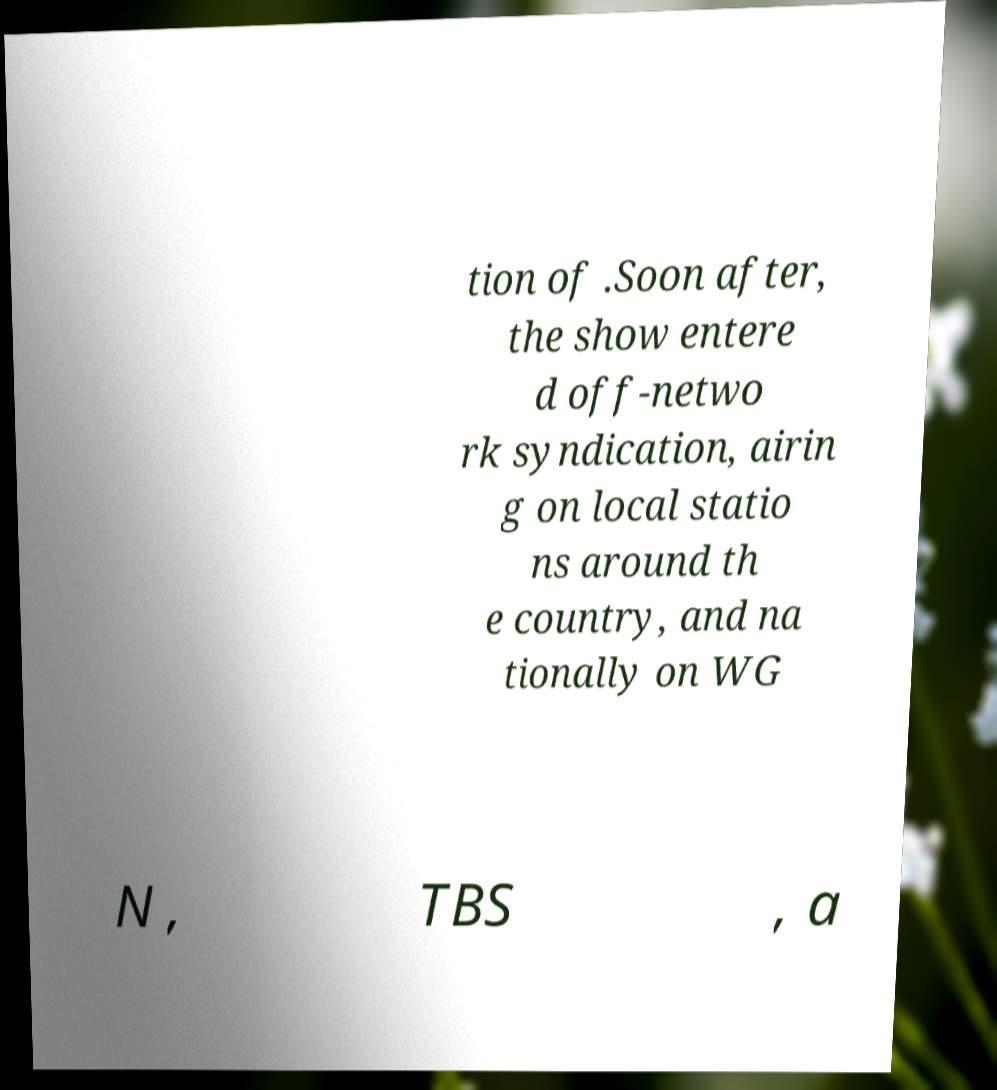Could you assist in decoding the text presented in this image and type it out clearly? tion of .Soon after, the show entere d off-netwo rk syndication, airin g on local statio ns around th e country, and na tionally on WG N , TBS , a 